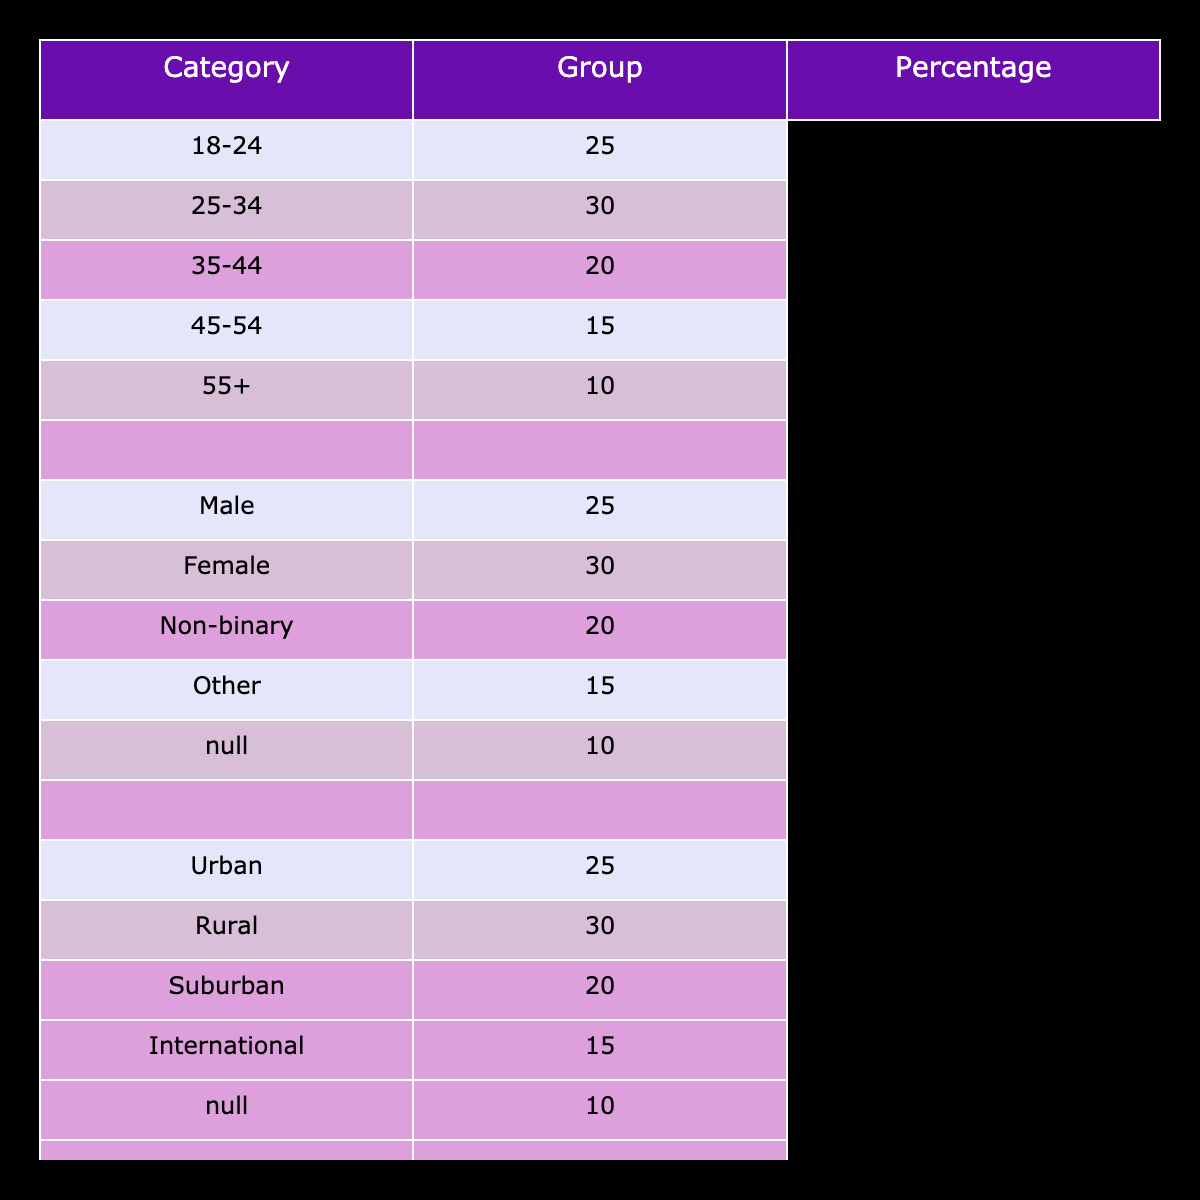What percentage of the audience is aged 25-34? The table lists the age group along with their respective percentages. Referring to the "Age Group" column, the percentage for the age group 25-34 is 30.
Answer: 30 Which gender group has the highest percentage in the audience? Looking at the "Gender Distribution" column and their respective percentages, the highest percentage is for females at 55.
Answer: Female Is the percentage of urban attendees greater than that of rural attendees? The table lists urban attendees at 60% and rural attendees at 20%. Since 60 is greater than 20, it confirms the statement is true.
Answer: Yes What is the combined percentage of the audience that is aged 35-44 and 45-54? To find this, we add the percentages of the two age groups: 20 (for 35-44) + 15 (for 45-54) equals 35.
Answer: 35 Is it true that there are no attendees from the 'Other' gender category? The table shows a percentage of 5 for the 'Other' gender category under "Gender Distribution," meaning there are indeed attendees from this group.
Answer: No What percentage of the total audience falls within the age groups below 35? To find this, we sum the percentages for the age groups 18-24 and 25-34: 25 (for 18-24) + 30 (for 25-34) equals 55.
Answer: 55 What is the location with the lowest percentage of attendees? Reviewing the "Location" column and their respective percentages shows that the 'International' location has the lowest percentage at 5.
Answer: International How many total percentage points are accounted for by the age groups 55 and older? The table shows 10% for age group 55 and older, so this is the total.
Answer: 10 Is the percentage of male attendees less than 50%? The percentage of male attendees is clearly stated as 40 in the table, which is indeed less than 50.
Answer: Yes 